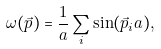<formula> <loc_0><loc_0><loc_500><loc_500>\omega ( \vec { p } ) = \frac { 1 } { a } \sum _ { i } \sin ( \vec { p } _ { i } a ) ,</formula> 